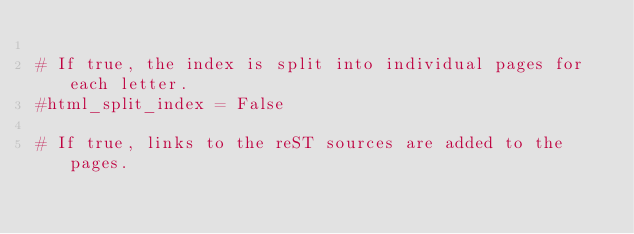<code> <loc_0><loc_0><loc_500><loc_500><_Python_>
# If true, the index is split into individual pages for each letter.
#html_split_index = False

# If true, links to the reST sources are added to the pages.</code> 